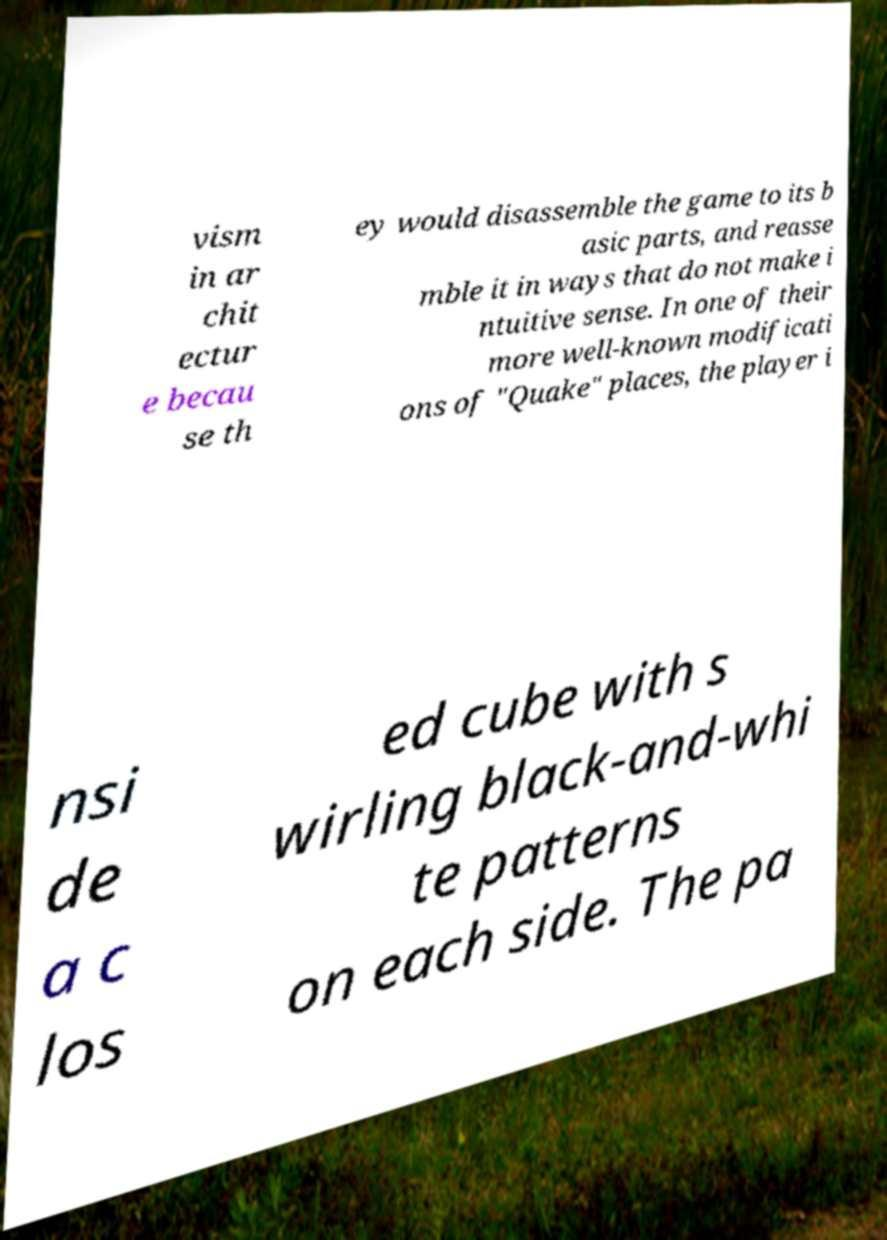Can you accurately transcribe the text from the provided image for me? vism in ar chit ectur e becau se th ey would disassemble the game to its b asic parts, and reasse mble it in ways that do not make i ntuitive sense. In one of their more well-known modificati ons of "Quake" places, the player i nsi de a c los ed cube with s wirling black-and-whi te patterns on each side. The pa 